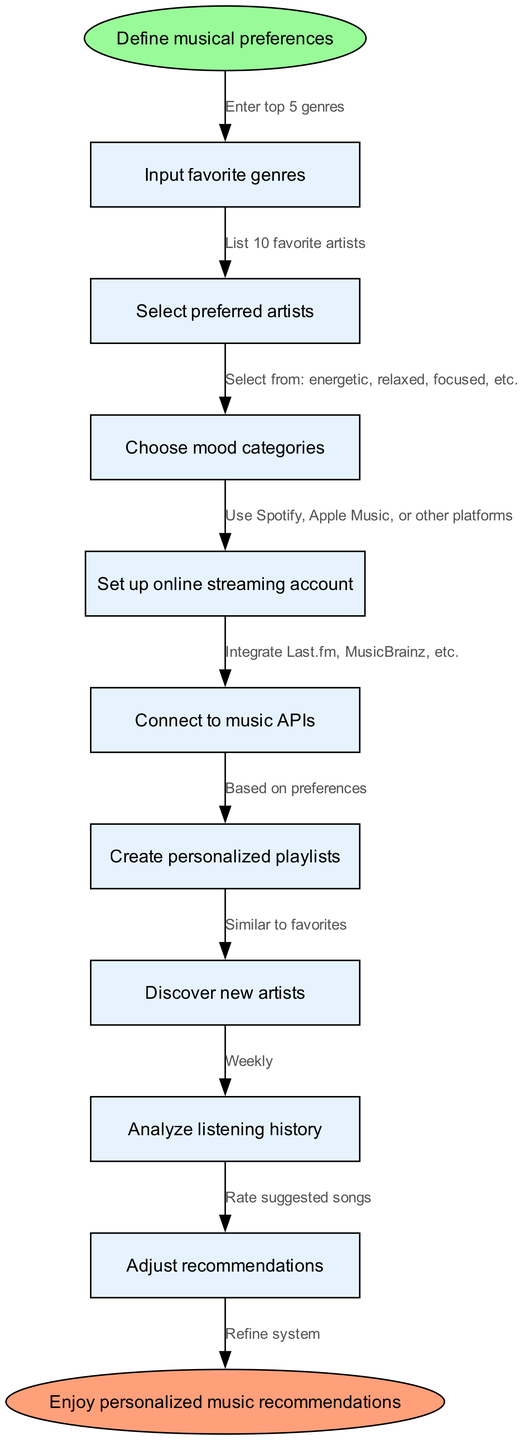What is the first step in the music recommendation system? The first step is defined as 'Define musical preferences' in the start node.
Answer: Define musical preferences How many nodes are present in the diagram? There are 9 nodes in total: 1 start node, 7 intermediate nodes, and 1 end node.
Answer: 9 What mood categories can be selected? The mood categories can be selected from options such as energetic, relaxed, or focused, as indicated in the diagram.
Answer: Energetic, relaxed, focused, etc What is the final outcome of the music recommendation process? The end node specifies that the final outcome of following the instructions is to 'Enjoy personalized music recommendations.'
Answer: Enjoy personalized music recommendations How many favorite artists are to be listed in the recommendations? The edges specify to list 10 favorite artists after entering top 5 genres.
Answer: 10 Which node comes after selecting preferred artists? After 'Select preferred artists' the next node is 'Choose mood categories'.
Answer: Choose mood categories What needs to be set up for accessing the music services? The instruction to 'Set up online streaming account' needs to be followed for accessing music services.
Answer: Set up online streaming account What do you do with suggested songs in the recommendation system? Suggested songs should be rated as per the instruction outlined in the edges of the diagram.
Answer: Rate suggested songs Which APIs are to be connected in this system? The diagram specifies connecting to music APIs such as Last.fm and MusicBrainz.
Answer: Last.fm, MusicBrainz 